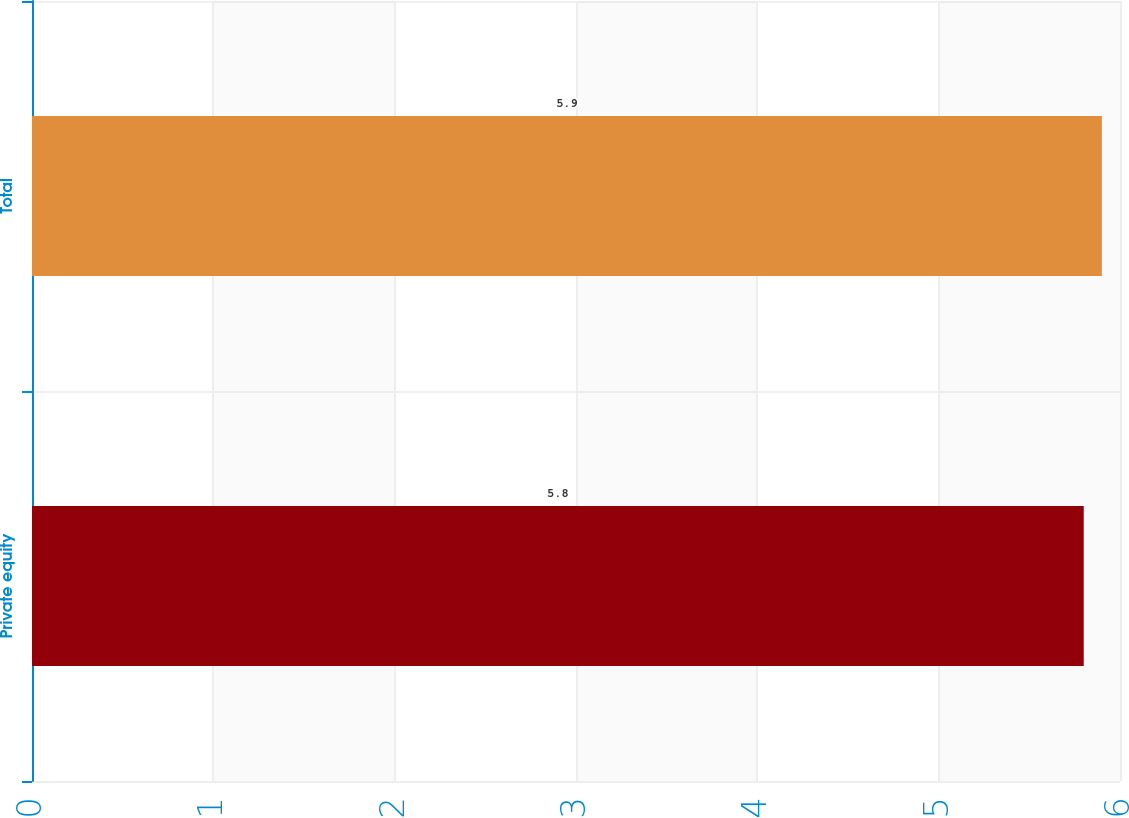<chart> <loc_0><loc_0><loc_500><loc_500><bar_chart><fcel>Private equity<fcel>Total<nl><fcel>5.8<fcel>5.9<nl></chart> 